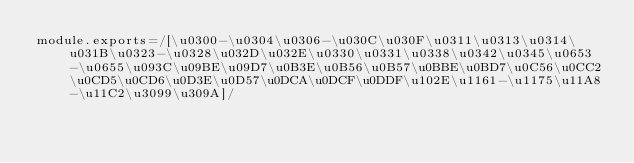Convert code to text. <code><loc_0><loc_0><loc_500><loc_500><_JavaScript_>module.exports=/[\u0300-\u0304\u0306-\u030C\u030F\u0311\u0313\u0314\u031B\u0323-\u0328\u032D\u032E\u0330\u0331\u0338\u0342\u0345\u0653-\u0655\u093C\u09BE\u09D7\u0B3E\u0B56\u0B57\u0BBE\u0BD7\u0C56\u0CC2\u0CD5\u0CD6\u0D3E\u0D57\u0DCA\u0DCF\u0DDF\u102E\u1161-\u1175\u11A8-\u11C2\u3099\u309A]/</code> 